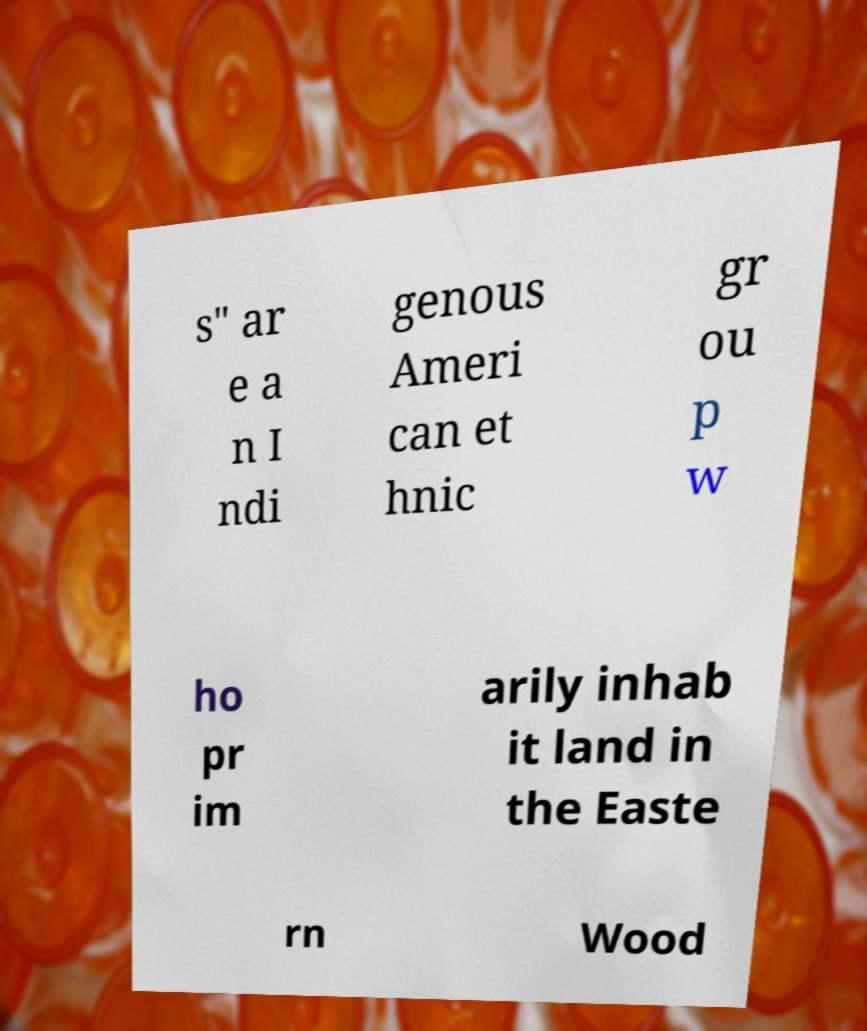Could you extract and type out the text from this image? s" ar e a n I ndi genous Ameri can et hnic gr ou p w ho pr im arily inhab it land in the Easte rn Wood 